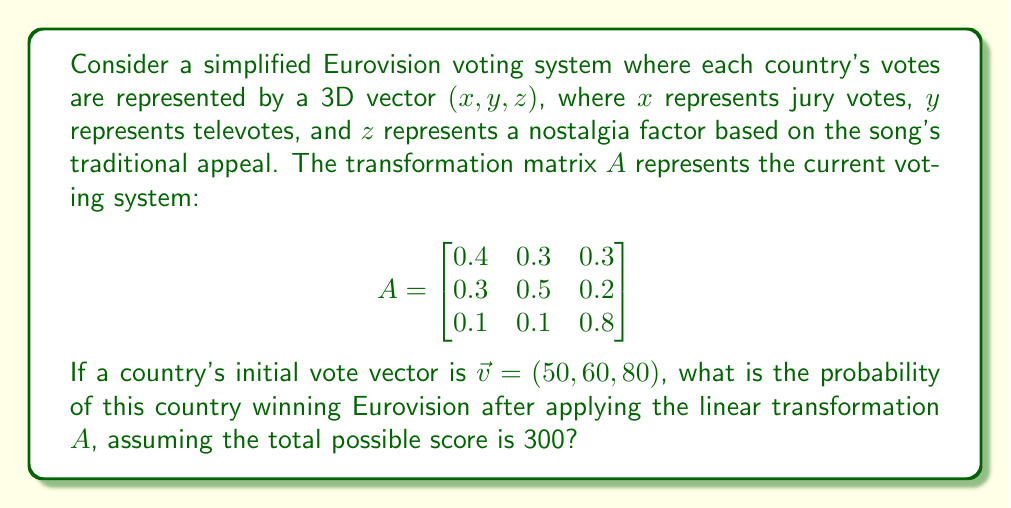Solve this math problem. Let's approach this step-by-step:

1) First, we need to apply the linear transformation $A$ to the initial vote vector $\vec{v}$:

   $A\vec{v} = \begin{bmatrix}
   0.4 & 0.3 & 0.3 \\
   0.3 & 0.5 & 0.2 \\
   0.1 & 0.1 & 0.8
   \end{bmatrix} \begin{pmatrix} 50 \\ 60 \\ 80 \end{pmatrix}$

2) Let's compute this multiplication:

   $\begin{pmatrix}
   (0.4 \times 50) + (0.3 \times 60) + (0.3 \times 80) \\
   (0.3 \times 50) + (0.5 \times 60) + (0.2 \times 80) \\
   (0.1 \times 50) + (0.1 \times 60) + (0.8 \times 80)
   \end{pmatrix}$

3) Simplifying:

   $\begin{pmatrix}
   20 + 18 + 24 \\
   15 + 30 + 16 \\
   5 + 6 + 64
   \end{pmatrix} = \begin{pmatrix} 62 \\ 61 \\ 75 \end{pmatrix}$

4) The transformed vector is $(62, 61, 75)$. To find the total score, we sum these components:

   $62 + 61 + 75 = 198$

5) The probability of winning is the ratio of the country's score to the total possible score:

   $P(\text{winning}) = \frac{198}{300} = 0.66$

Therefore, the probability of this country winning Eurovision after applying the linear transformation is 0.66 or 66%.
Answer: 0.66 